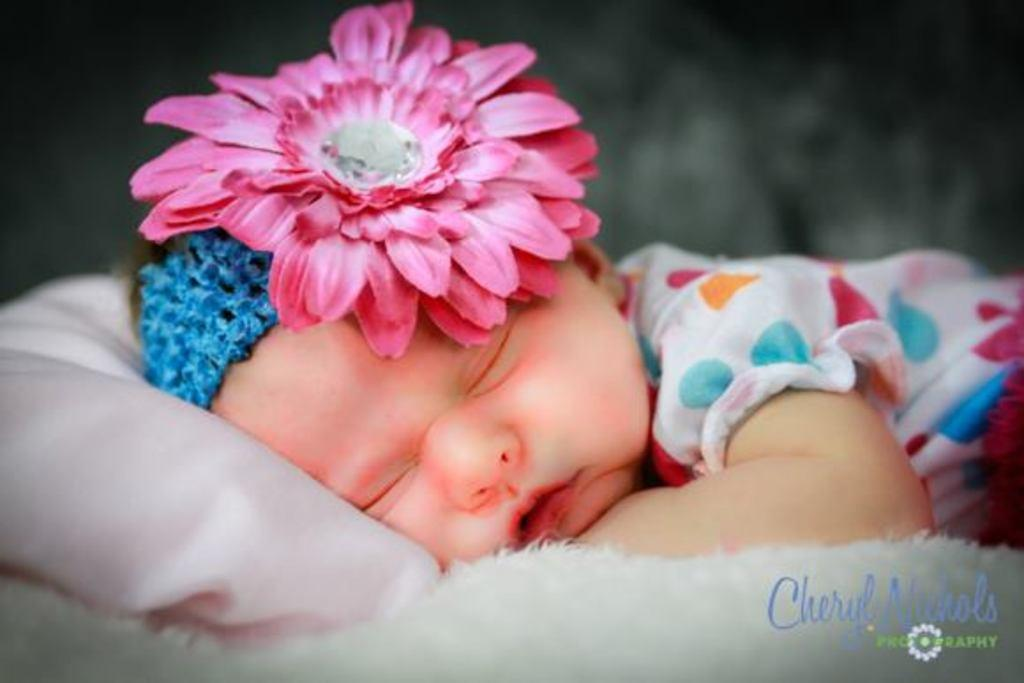What is the main subject of the image? There is a baby in the image. What is the baby doing in the image? The baby is sleeping. Where is the baby located in the image? The baby is in the center of the image. What is present at the bottom of the image? There is a blanket at the bottom of the image. What type of fiction is the baby reading in the image? There is no fiction present in the image, as the baby is sleeping and not reading. 